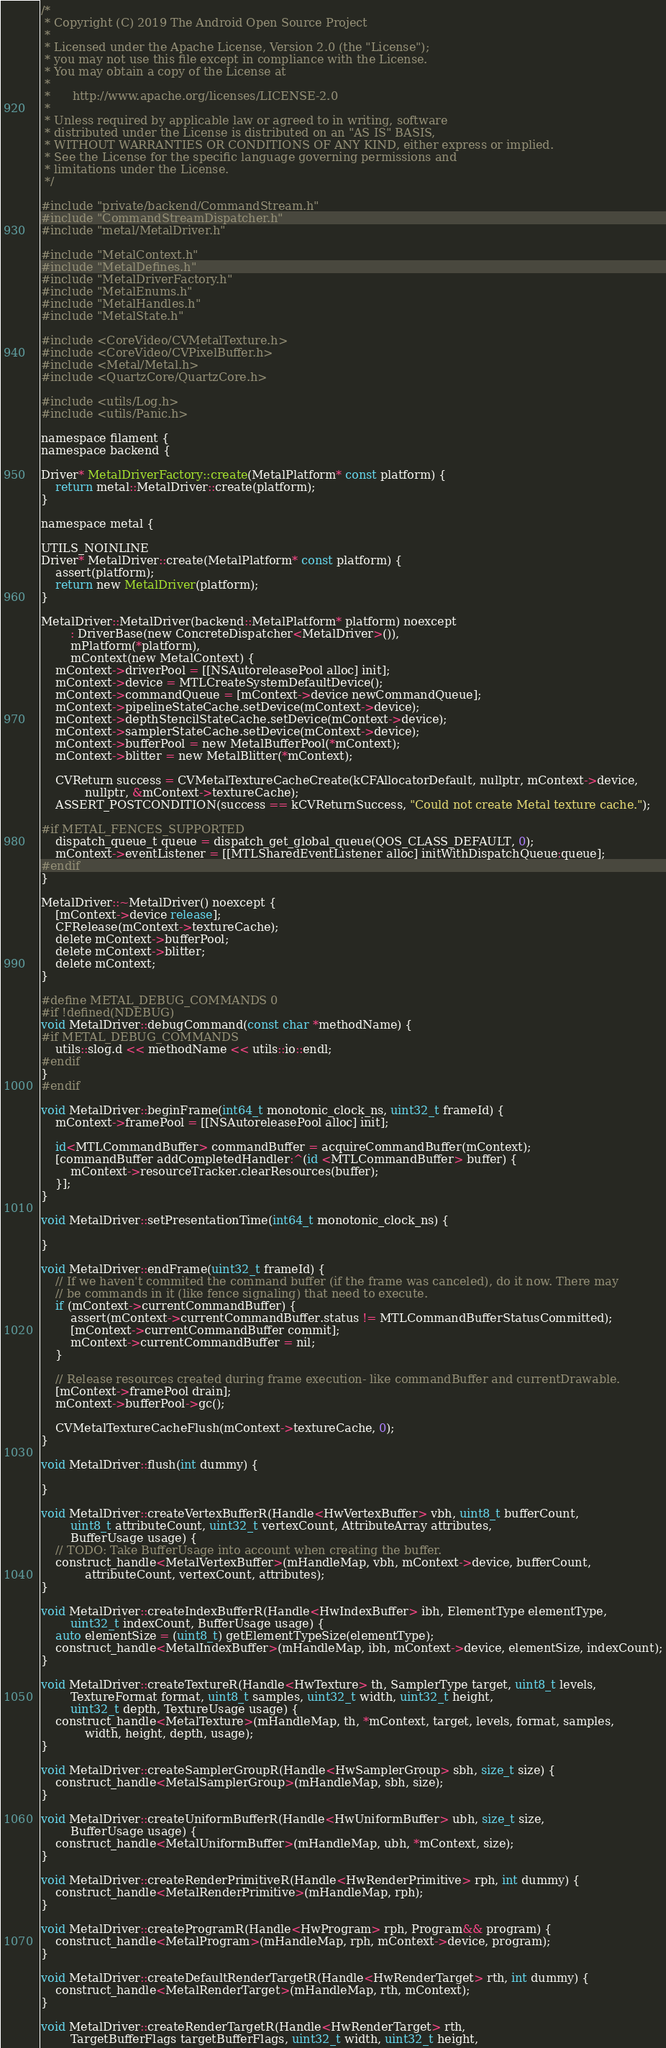<code> <loc_0><loc_0><loc_500><loc_500><_ObjectiveC_>/*
 * Copyright (C) 2019 The Android Open Source Project
 *
 * Licensed under the Apache License, Version 2.0 (the "License");
 * you may not use this file except in compliance with the License.
 * You may obtain a copy of the License at
 *
 *      http://www.apache.org/licenses/LICENSE-2.0
 *
 * Unless required by applicable law or agreed to in writing, software
 * distributed under the License is distributed on an "AS IS" BASIS,
 * WITHOUT WARRANTIES OR CONDITIONS OF ANY KIND, either express or implied.
 * See the License for the specific language governing permissions and
 * limitations under the License.
 */

#include "private/backend/CommandStream.h"
#include "CommandStreamDispatcher.h"
#include "metal/MetalDriver.h"

#include "MetalContext.h"
#include "MetalDefines.h"
#include "MetalDriverFactory.h"
#include "MetalEnums.h"
#include "MetalHandles.h"
#include "MetalState.h"

#include <CoreVideo/CVMetalTexture.h>
#include <CoreVideo/CVPixelBuffer.h>
#include <Metal/Metal.h>
#include <QuartzCore/QuartzCore.h>

#include <utils/Log.h>
#include <utils/Panic.h>

namespace filament {
namespace backend {

Driver* MetalDriverFactory::create(MetalPlatform* const platform) {
    return metal::MetalDriver::create(platform);
}

namespace metal {

UTILS_NOINLINE
Driver* MetalDriver::create(MetalPlatform* const platform) {
    assert(platform);
    return new MetalDriver(platform);
}

MetalDriver::MetalDriver(backend::MetalPlatform* platform) noexcept
        : DriverBase(new ConcreteDispatcher<MetalDriver>()),
        mPlatform(*platform),
        mContext(new MetalContext) {
    mContext->driverPool = [[NSAutoreleasePool alloc] init];
    mContext->device = MTLCreateSystemDefaultDevice();
    mContext->commandQueue = [mContext->device newCommandQueue];
    mContext->pipelineStateCache.setDevice(mContext->device);
    mContext->depthStencilStateCache.setDevice(mContext->device);
    mContext->samplerStateCache.setDevice(mContext->device);
    mContext->bufferPool = new MetalBufferPool(*mContext);
    mContext->blitter = new MetalBlitter(*mContext);

    CVReturn success = CVMetalTextureCacheCreate(kCFAllocatorDefault, nullptr, mContext->device,
            nullptr, &mContext->textureCache);
    ASSERT_POSTCONDITION(success == kCVReturnSuccess, "Could not create Metal texture cache.");

#if METAL_FENCES_SUPPORTED
    dispatch_queue_t queue = dispatch_get_global_queue(QOS_CLASS_DEFAULT, 0);
    mContext->eventListener = [[MTLSharedEventListener alloc] initWithDispatchQueue:queue];
#endif
}

MetalDriver::~MetalDriver() noexcept {
    [mContext->device release];
    CFRelease(mContext->textureCache);
    delete mContext->bufferPool;
    delete mContext->blitter;
    delete mContext;
}

#define METAL_DEBUG_COMMANDS 0
#if !defined(NDEBUG)
void MetalDriver::debugCommand(const char *methodName) {
#if METAL_DEBUG_COMMANDS
    utils::slog.d << methodName << utils::io::endl;
#endif
}
#endif

void MetalDriver::beginFrame(int64_t monotonic_clock_ns, uint32_t frameId) {
    mContext->framePool = [[NSAutoreleasePool alloc] init];

    id<MTLCommandBuffer> commandBuffer = acquireCommandBuffer(mContext);
    [commandBuffer addCompletedHandler:^(id <MTLCommandBuffer> buffer) {
        mContext->resourceTracker.clearResources(buffer);
    }];
}

void MetalDriver::setPresentationTime(int64_t monotonic_clock_ns) {

}

void MetalDriver::endFrame(uint32_t frameId) {
    // If we haven't commited the command buffer (if the frame was canceled), do it now. There may
    // be commands in it (like fence signaling) that need to execute.
    if (mContext->currentCommandBuffer) {
        assert(mContext->currentCommandBuffer.status != MTLCommandBufferStatusCommitted);
        [mContext->currentCommandBuffer commit];
        mContext->currentCommandBuffer = nil;
    }

    // Release resources created during frame execution- like commandBuffer and currentDrawable.
    [mContext->framePool drain];
    mContext->bufferPool->gc();

    CVMetalTextureCacheFlush(mContext->textureCache, 0);
}

void MetalDriver::flush(int dummy) {

}

void MetalDriver::createVertexBufferR(Handle<HwVertexBuffer> vbh, uint8_t bufferCount,
        uint8_t attributeCount, uint32_t vertexCount, AttributeArray attributes,
        BufferUsage usage) {
    // TODO: Take BufferUsage into account when creating the buffer.
    construct_handle<MetalVertexBuffer>(mHandleMap, vbh, mContext->device, bufferCount,
            attributeCount, vertexCount, attributes);
}

void MetalDriver::createIndexBufferR(Handle<HwIndexBuffer> ibh, ElementType elementType,
        uint32_t indexCount, BufferUsage usage) {
    auto elementSize = (uint8_t) getElementTypeSize(elementType);
    construct_handle<MetalIndexBuffer>(mHandleMap, ibh, mContext->device, elementSize, indexCount);
}

void MetalDriver::createTextureR(Handle<HwTexture> th, SamplerType target, uint8_t levels,
        TextureFormat format, uint8_t samples, uint32_t width, uint32_t height,
        uint32_t depth, TextureUsage usage) {
    construct_handle<MetalTexture>(mHandleMap, th, *mContext, target, levels, format, samples,
            width, height, depth, usage);
}

void MetalDriver::createSamplerGroupR(Handle<HwSamplerGroup> sbh, size_t size) {
    construct_handle<MetalSamplerGroup>(mHandleMap, sbh, size);
}

void MetalDriver::createUniformBufferR(Handle<HwUniformBuffer> ubh, size_t size,
        BufferUsage usage) {
    construct_handle<MetalUniformBuffer>(mHandleMap, ubh, *mContext, size);
}

void MetalDriver::createRenderPrimitiveR(Handle<HwRenderPrimitive> rph, int dummy) {
    construct_handle<MetalRenderPrimitive>(mHandleMap, rph);
}

void MetalDriver::createProgramR(Handle<HwProgram> rph, Program&& program) {
    construct_handle<MetalProgram>(mHandleMap, rph, mContext->device, program);
}

void MetalDriver::createDefaultRenderTargetR(Handle<HwRenderTarget> rth, int dummy) {
    construct_handle<MetalRenderTarget>(mHandleMap, rth, mContext);
}

void MetalDriver::createRenderTargetR(Handle<HwRenderTarget> rth,
        TargetBufferFlags targetBufferFlags, uint32_t width, uint32_t height,</code> 